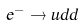Convert formula to latex. <formula><loc_0><loc_0><loc_500><loc_500>e ^ { - } \to u d d</formula> 